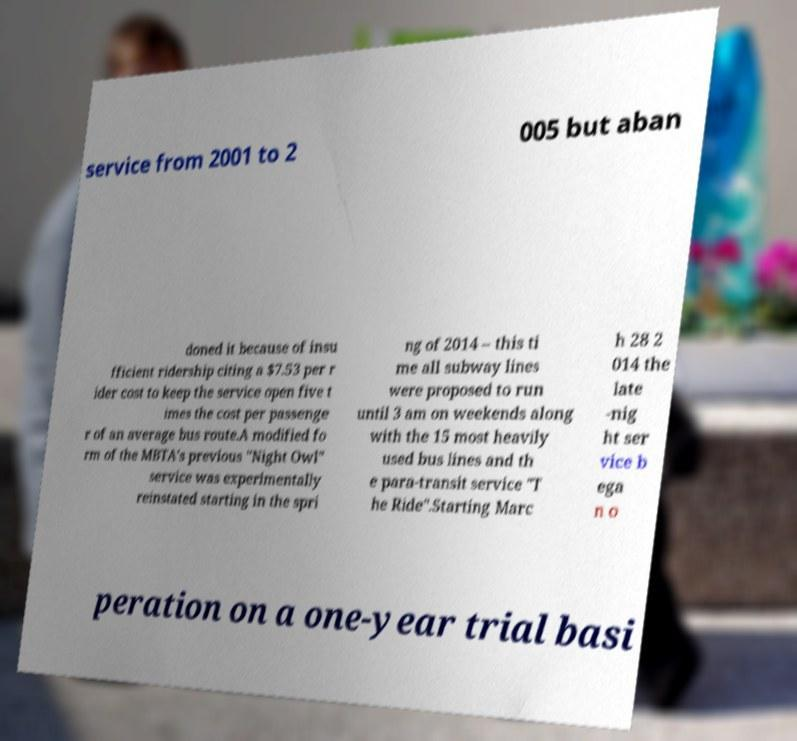Please identify and transcribe the text found in this image. service from 2001 to 2 005 but aban doned it because of insu fficient ridership citing a $7.53 per r ider cost to keep the service open five t imes the cost per passenge r of an average bus route.A modified fo rm of the MBTA's previous "Night Owl" service was experimentally reinstated starting in the spri ng of 2014 – this ti me all subway lines were proposed to run until 3 am on weekends along with the 15 most heavily used bus lines and th e para-transit service "T he Ride".Starting Marc h 28 2 014 the late -nig ht ser vice b ega n o peration on a one-year trial basi 